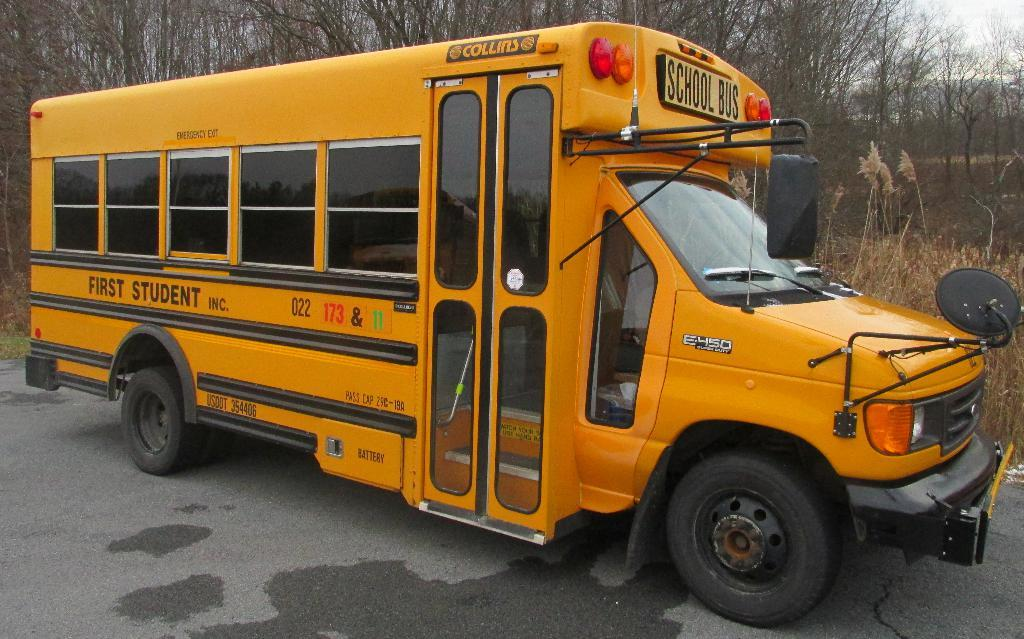What type of vehicle is in the image? There is a yellow bus in the image. What can be seen on the right side of the image? There are plants on the right side of the image. What is visible in the background of the image? There are trees visible in the background of the image. What action is the bus performing in the image? The bus is not performing any action in the image; it is stationary. Can you recite a verse that is written on the bus in the image? There is no verse written on the bus in the image. 